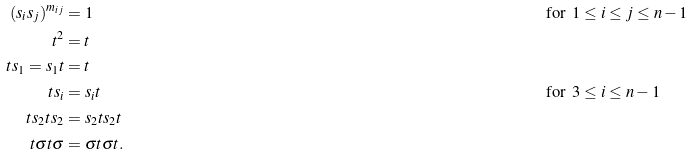Convert formula to latex. <formula><loc_0><loc_0><loc_500><loc_500>( s _ { i } s _ { j } ) ^ { m _ { i j } } & = 1 & & \text {for\, $1\leq i\leq j\leq n-1$} \\ t ^ { 2 } & = t \\ t s _ { 1 } = s _ { 1 } t & = t \\ t s _ { i } & = s _ { i } t & & \text {for\, $3\leq i\leq n-1$} \\ t s _ { 2 } t s _ { 2 } & = s _ { 2 } t s _ { 2 } t \\ t \sigma t \sigma & = \sigma t \sigma t .</formula> 